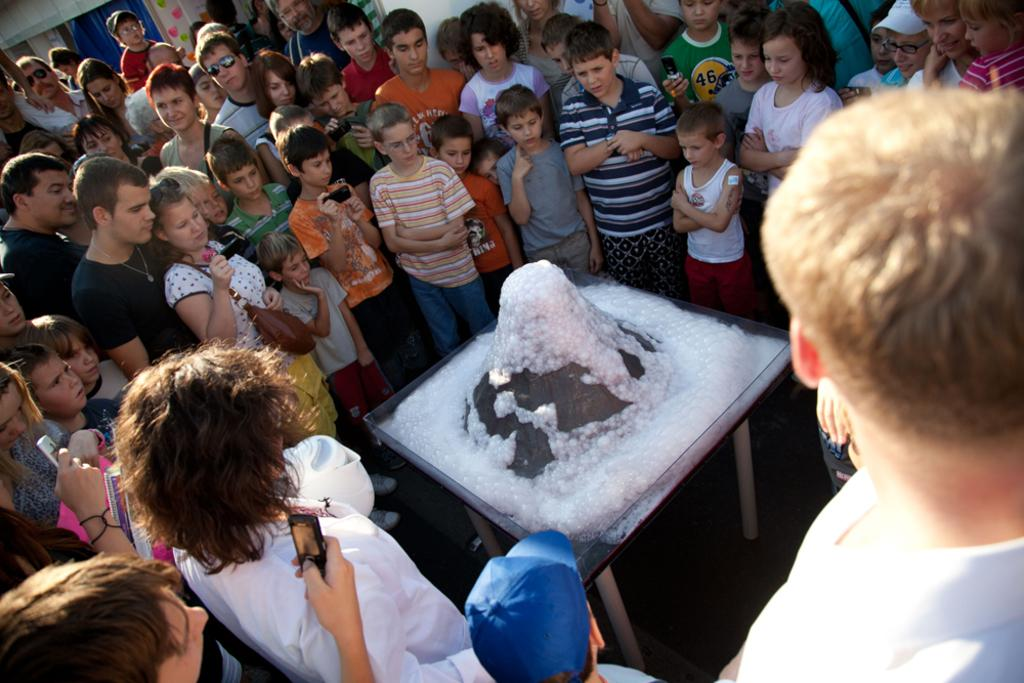How many people are in the group visible in the image? There is a group of people in the image, but the exact number is not specified. What are some people in the group doing? Some people in the group are holding mobile phones. What color is the object in the image? There is a black color object in the image. What is on the table in the image? There is white color foam on a table in the image. What type of zebra can be seen drinking wine in the image? There is no zebra or wine present in the image. What news is being discussed by the group in the image? The image does not provide any information about the group discussing news. 